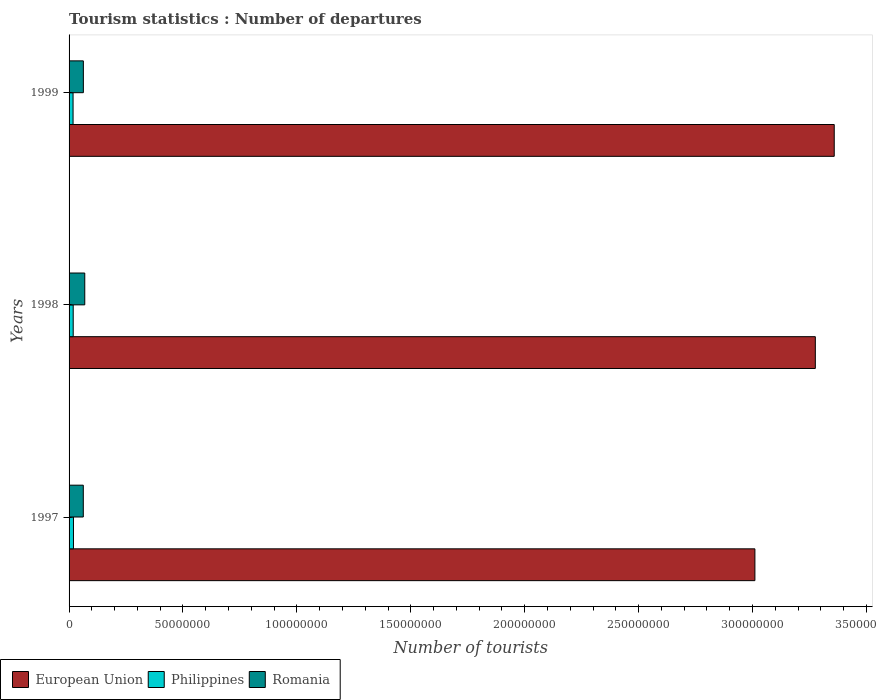How many different coloured bars are there?
Your answer should be very brief. 3. How many groups of bars are there?
Keep it short and to the point. 3. Are the number of bars per tick equal to the number of legend labels?
Provide a succinct answer. Yes. What is the number of tourist departures in Romania in 1997?
Make the answer very short. 6.24e+06. Across all years, what is the maximum number of tourist departures in European Union?
Offer a terse response. 3.36e+08. Across all years, what is the minimum number of tourist departures in Romania?
Give a very brief answer. 6.24e+06. What is the total number of tourist departures in Philippines in the graph?
Make the answer very short. 5.50e+06. What is the difference between the number of tourist departures in Philippines in 1997 and that in 1999?
Your answer should be compact. 1.75e+05. What is the difference between the number of tourist departures in Romania in 1998 and the number of tourist departures in Philippines in 1997?
Offer a very short reply. 4.96e+06. What is the average number of tourist departures in Philippines per year?
Your answer should be very brief. 1.83e+06. In the year 1997, what is the difference between the number of tourist departures in Romania and number of tourist departures in Philippines?
Provide a succinct answer. 4.31e+06. In how many years, is the number of tourist departures in Philippines greater than 40000000 ?
Ensure brevity in your answer.  0. What is the ratio of the number of tourist departures in Philippines in 1997 to that in 1998?
Offer a very short reply. 1.06. Is the number of tourist departures in Philippines in 1997 less than that in 1998?
Keep it short and to the point. No. Is the difference between the number of tourist departures in Romania in 1997 and 1999 greater than the difference between the number of tourist departures in Philippines in 1997 and 1999?
Provide a short and direct response. No. What is the difference between the highest and the second highest number of tourist departures in European Union?
Provide a succinct answer. 8.30e+06. What is the difference between the highest and the lowest number of tourist departures in Romania?
Your response must be concise. 6.50e+05. Is the sum of the number of tourist departures in Philippines in 1998 and 1999 greater than the maximum number of tourist departures in European Union across all years?
Ensure brevity in your answer.  No. What does the 3rd bar from the top in 1998 represents?
Provide a succinct answer. European Union. What does the 1st bar from the bottom in 1999 represents?
Give a very brief answer. European Union. How many bars are there?
Your answer should be compact. 9. What is the difference between two consecutive major ticks on the X-axis?
Give a very brief answer. 5.00e+07. Are the values on the major ticks of X-axis written in scientific E-notation?
Give a very brief answer. No. Where does the legend appear in the graph?
Ensure brevity in your answer.  Bottom left. How many legend labels are there?
Your answer should be very brief. 3. What is the title of the graph?
Offer a very short reply. Tourism statistics : Number of departures. What is the label or title of the X-axis?
Offer a very short reply. Number of tourists. What is the label or title of the Y-axis?
Your answer should be very brief. Years. What is the Number of tourists in European Union in 1997?
Ensure brevity in your answer.  3.01e+08. What is the Number of tourists of Philippines in 1997?
Offer a terse response. 1.93e+06. What is the Number of tourists of Romania in 1997?
Your response must be concise. 6.24e+06. What is the Number of tourists of European Union in 1998?
Keep it short and to the point. 3.28e+08. What is the Number of tourists of Philippines in 1998?
Offer a terse response. 1.82e+06. What is the Number of tourists in Romania in 1998?
Make the answer very short. 6.89e+06. What is the Number of tourists in European Union in 1999?
Provide a short and direct response. 3.36e+08. What is the Number of tourists of Philippines in 1999?
Provide a short and direct response. 1.76e+06. What is the Number of tourists in Romania in 1999?
Your response must be concise. 6.27e+06. Across all years, what is the maximum Number of tourists of European Union?
Your response must be concise. 3.36e+08. Across all years, what is the maximum Number of tourists of Philippines?
Make the answer very short. 1.93e+06. Across all years, what is the maximum Number of tourists in Romania?
Ensure brevity in your answer.  6.89e+06. Across all years, what is the minimum Number of tourists in European Union?
Keep it short and to the point. 3.01e+08. Across all years, what is the minimum Number of tourists in Philippines?
Your response must be concise. 1.76e+06. Across all years, what is the minimum Number of tourists in Romania?
Your response must be concise. 6.24e+06. What is the total Number of tourists of European Union in the graph?
Give a very brief answer. 9.65e+08. What is the total Number of tourists of Philippines in the graph?
Offer a terse response. 5.50e+06. What is the total Number of tourists in Romania in the graph?
Provide a succinct answer. 1.94e+07. What is the difference between the Number of tourists in European Union in 1997 and that in 1998?
Keep it short and to the point. -2.65e+07. What is the difference between the Number of tourists of Philippines in 1997 and that in 1998?
Keep it short and to the point. 1.13e+05. What is the difference between the Number of tourists of Romania in 1997 and that in 1998?
Make the answer very short. -6.50e+05. What is the difference between the Number of tourists in European Union in 1997 and that in 1999?
Your answer should be compact. -3.48e+07. What is the difference between the Number of tourists in Philippines in 1997 and that in 1999?
Offer a very short reply. 1.75e+05. What is the difference between the Number of tourists of Romania in 1997 and that in 1999?
Provide a short and direct response. -3.10e+04. What is the difference between the Number of tourists in European Union in 1998 and that in 1999?
Give a very brief answer. -8.30e+06. What is the difference between the Number of tourists of Philippines in 1998 and that in 1999?
Offer a very short reply. 6.20e+04. What is the difference between the Number of tourists of Romania in 1998 and that in 1999?
Give a very brief answer. 6.19e+05. What is the difference between the Number of tourists in European Union in 1997 and the Number of tourists in Philippines in 1998?
Provide a succinct answer. 2.99e+08. What is the difference between the Number of tourists of European Union in 1997 and the Number of tourists of Romania in 1998?
Provide a succinct answer. 2.94e+08. What is the difference between the Number of tourists in Philippines in 1997 and the Number of tourists in Romania in 1998?
Provide a short and direct response. -4.96e+06. What is the difference between the Number of tourists of European Union in 1997 and the Number of tourists of Philippines in 1999?
Give a very brief answer. 2.99e+08. What is the difference between the Number of tourists in European Union in 1997 and the Number of tourists in Romania in 1999?
Make the answer very short. 2.95e+08. What is the difference between the Number of tourists of Philippines in 1997 and the Number of tourists of Romania in 1999?
Your response must be concise. -4.34e+06. What is the difference between the Number of tourists of European Union in 1998 and the Number of tourists of Philippines in 1999?
Keep it short and to the point. 3.26e+08. What is the difference between the Number of tourists of European Union in 1998 and the Number of tourists of Romania in 1999?
Offer a terse response. 3.21e+08. What is the difference between the Number of tourists of Philippines in 1998 and the Number of tourists of Romania in 1999?
Ensure brevity in your answer.  -4.46e+06. What is the average Number of tourists in European Union per year?
Provide a short and direct response. 3.22e+08. What is the average Number of tourists of Philippines per year?
Give a very brief answer. 1.83e+06. What is the average Number of tourists of Romania per year?
Offer a terse response. 6.47e+06. In the year 1997, what is the difference between the Number of tourists of European Union and Number of tourists of Philippines?
Make the answer very short. 2.99e+08. In the year 1997, what is the difference between the Number of tourists of European Union and Number of tourists of Romania?
Keep it short and to the point. 2.95e+08. In the year 1997, what is the difference between the Number of tourists in Philippines and Number of tourists in Romania?
Offer a very short reply. -4.31e+06. In the year 1998, what is the difference between the Number of tourists in European Union and Number of tourists in Philippines?
Your answer should be compact. 3.26e+08. In the year 1998, what is the difference between the Number of tourists of European Union and Number of tourists of Romania?
Ensure brevity in your answer.  3.21e+08. In the year 1998, what is the difference between the Number of tourists in Philippines and Number of tourists in Romania?
Make the answer very short. -5.08e+06. In the year 1999, what is the difference between the Number of tourists in European Union and Number of tourists in Philippines?
Give a very brief answer. 3.34e+08. In the year 1999, what is the difference between the Number of tourists of European Union and Number of tourists of Romania?
Keep it short and to the point. 3.30e+08. In the year 1999, what is the difference between the Number of tourists in Philippines and Number of tourists in Romania?
Make the answer very short. -4.52e+06. What is the ratio of the Number of tourists in European Union in 1997 to that in 1998?
Make the answer very short. 0.92. What is the ratio of the Number of tourists in Philippines in 1997 to that in 1998?
Give a very brief answer. 1.06. What is the ratio of the Number of tourists of Romania in 1997 to that in 1998?
Your response must be concise. 0.91. What is the ratio of the Number of tourists of European Union in 1997 to that in 1999?
Offer a very short reply. 0.9. What is the ratio of the Number of tourists of Philippines in 1997 to that in 1999?
Offer a very short reply. 1.1. What is the ratio of the Number of tourists of European Union in 1998 to that in 1999?
Offer a very short reply. 0.98. What is the ratio of the Number of tourists of Philippines in 1998 to that in 1999?
Provide a short and direct response. 1.04. What is the ratio of the Number of tourists in Romania in 1998 to that in 1999?
Offer a terse response. 1.1. What is the difference between the highest and the second highest Number of tourists in European Union?
Your answer should be compact. 8.30e+06. What is the difference between the highest and the second highest Number of tourists of Philippines?
Provide a succinct answer. 1.13e+05. What is the difference between the highest and the second highest Number of tourists in Romania?
Offer a terse response. 6.19e+05. What is the difference between the highest and the lowest Number of tourists in European Union?
Your answer should be very brief. 3.48e+07. What is the difference between the highest and the lowest Number of tourists of Philippines?
Give a very brief answer. 1.75e+05. What is the difference between the highest and the lowest Number of tourists of Romania?
Offer a terse response. 6.50e+05. 